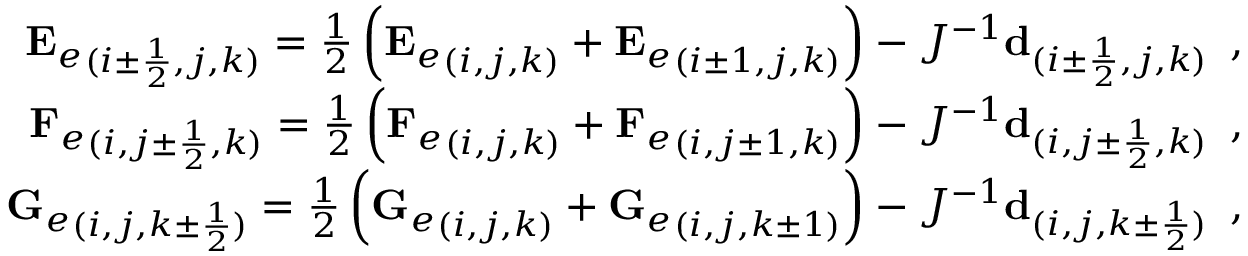<formula> <loc_0><loc_0><loc_500><loc_500>\begin{array} { r } { { E _ { e } } _ { ( i \pm \frac { 1 } { 2 } , j , k ) } = \frac { 1 } { 2 } \left ( { E _ { e } } _ { ( i , j , k ) } + { E _ { e } } _ { ( i \pm 1 , j , k ) } \right ) - J ^ { - 1 } d _ { ( i \pm \frac { 1 } { 2 } , j , k ) } \, , } \\ { { F _ { e } } _ { ( i , j \pm \frac { 1 } { 2 } , k ) } = \frac { 1 } { 2 } \left ( { F _ { e } } _ { ( i , j , k ) } + { F _ { e } } _ { ( i , j \pm 1 , k ) } \right ) - J ^ { - 1 } d _ { ( i , j \pm \frac { 1 } { 2 } , k ) } \, , } \\ { { G _ { e } } _ { ( i , j , k \pm \frac { 1 } { 2 } ) } = \frac { 1 } { 2 } \left ( { G _ { e } } _ { ( i , j , k ) } + { G _ { e } } _ { ( i , j , k \pm 1 ) } \right ) - J ^ { - 1 } d _ { ( i , j , k \pm \frac { 1 } { 2 } ) } \, , } \end{array}</formula> 